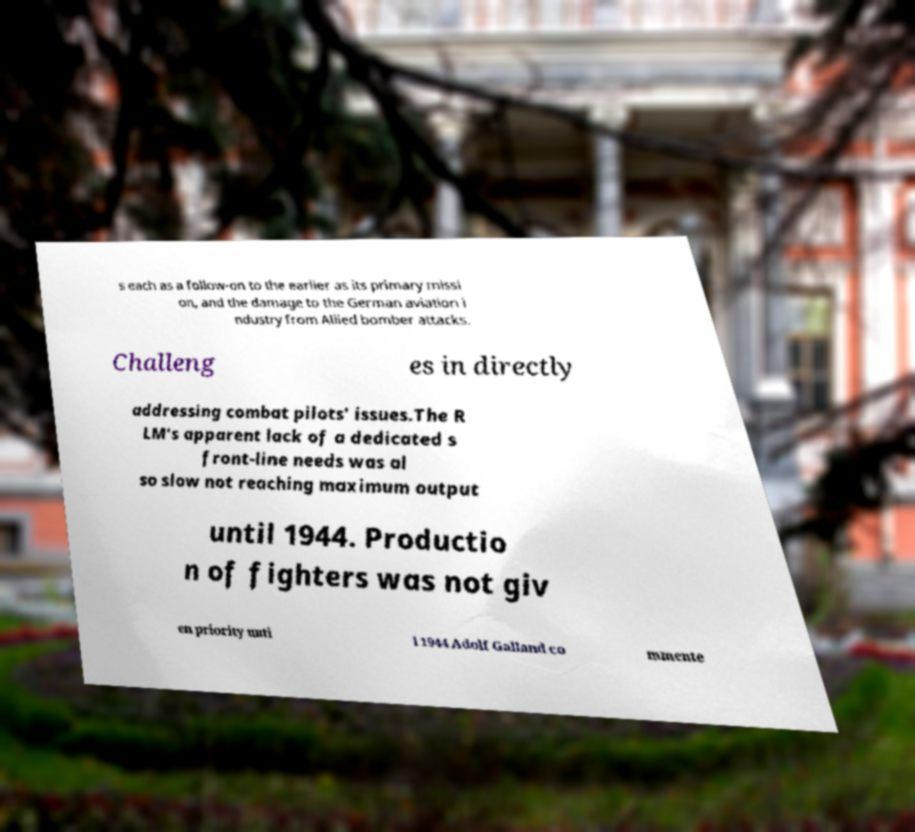There's text embedded in this image that I need extracted. Can you transcribe it verbatim? s each as a follow-on to the earlier as its primary missi on, and the damage to the German aviation i ndustry from Allied bomber attacks. Challeng es in directly addressing combat pilots' issues.The R LM's apparent lack of a dedicated s front-line needs was al so slow not reaching maximum output until 1944. Productio n of fighters was not giv en priority unti l 1944 Adolf Galland co mmente 